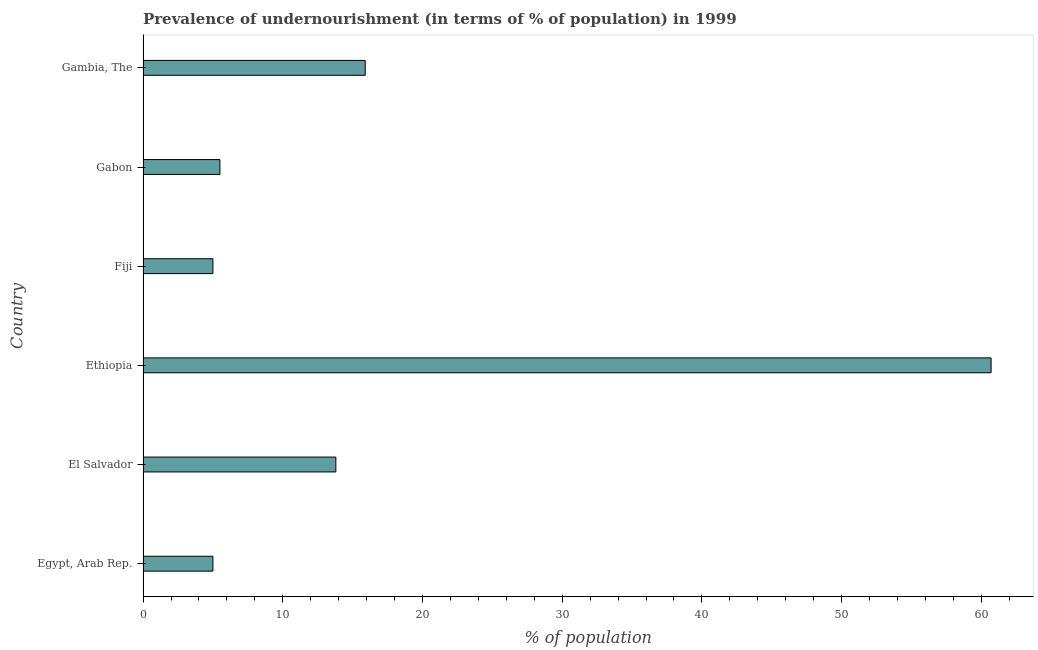What is the title of the graph?
Give a very brief answer. Prevalence of undernourishment (in terms of % of population) in 1999. What is the label or title of the X-axis?
Give a very brief answer. % of population. Across all countries, what is the maximum percentage of undernourished population?
Offer a very short reply. 60.7. In which country was the percentage of undernourished population maximum?
Give a very brief answer. Ethiopia. In which country was the percentage of undernourished population minimum?
Your answer should be compact. Egypt, Arab Rep. What is the sum of the percentage of undernourished population?
Keep it short and to the point. 105.9. What is the difference between the percentage of undernourished population in Ethiopia and Gambia, The?
Offer a very short reply. 44.8. What is the average percentage of undernourished population per country?
Offer a very short reply. 17.65. What is the median percentage of undernourished population?
Provide a short and direct response. 9.65. In how many countries, is the percentage of undernourished population greater than 26 %?
Your answer should be compact. 1. Is the difference between the percentage of undernourished population in Ethiopia and Fiji greater than the difference between any two countries?
Offer a terse response. Yes. What is the difference between the highest and the second highest percentage of undernourished population?
Offer a very short reply. 44.8. Is the sum of the percentage of undernourished population in El Salvador and Fiji greater than the maximum percentage of undernourished population across all countries?
Give a very brief answer. No. What is the difference between the highest and the lowest percentage of undernourished population?
Give a very brief answer. 55.7. How many countries are there in the graph?
Offer a very short reply. 6. What is the difference between two consecutive major ticks on the X-axis?
Provide a short and direct response. 10. Are the values on the major ticks of X-axis written in scientific E-notation?
Provide a succinct answer. No. What is the % of population of Egypt, Arab Rep.?
Give a very brief answer. 5. What is the % of population in Ethiopia?
Your answer should be very brief. 60.7. What is the % of population of Gambia, The?
Provide a short and direct response. 15.9. What is the difference between the % of population in Egypt, Arab Rep. and Ethiopia?
Your answer should be compact. -55.7. What is the difference between the % of population in Egypt, Arab Rep. and Fiji?
Make the answer very short. 0. What is the difference between the % of population in El Salvador and Ethiopia?
Provide a succinct answer. -46.9. What is the difference between the % of population in El Salvador and Fiji?
Make the answer very short. 8.8. What is the difference between the % of population in El Salvador and Gabon?
Provide a short and direct response. 8.3. What is the difference between the % of population in El Salvador and Gambia, The?
Your response must be concise. -2.1. What is the difference between the % of population in Ethiopia and Fiji?
Your answer should be compact. 55.7. What is the difference between the % of population in Ethiopia and Gabon?
Offer a very short reply. 55.2. What is the difference between the % of population in Ethiopia and Gambia, The?
Offer a terse response. 44.8. What is the difference between the % of population in Fiji and Gabon?
Provide a short and direct response. -0.5. What is the difference between the % of population in Fiji and Gambia, The?
Your answer should be compact. -10.9. What is the difference between the % of population in Gabon and Gambia, The?
Your response must be concise. -10.4. What is the ratio of the % of population in Egypt, Arab Rep. to that in El Salvador?
Provide a short and direct response. 0.36. What is the ratio of the % of population in Egypt, Arab Rep. to that in Ethiopia?
Your answer should be compact. 0.08. What is the ratio of the % of population in Egypt, Arab Rep. to that in Fiji?
Your answer should be very brief. 1. What is the ratio of the % of population in Egypt, Arab Rep. to that in Gabon?
Offer a terse response. 0.91. What is the ratio of the % of population in Egypt, Arab Rep. to that in Gambia, The?
Ensure brevity in your answer.  0.31. What is the ratio of the % of population in El Salvador to that in Ethiopia?
Ensure brevity in your answer.  0.23. What is the ratio of the % of population in El Salvador to that in Fiji?
Offer a very short reply. 2.76. What is the ratio of the % of population in El Salvador to that in Gabon?
Give a very brief answer. 2.51. What is the ratio of the % of population in El Salvador to that in Gambia, The?
Your answer should be compact. 0.87. What is the ratio of the % of population in Ethiopia to that in Fiji?
Your answer should be compact. 12.14. What is the ratio of the % of population in Ethiopia to that in Gabon?
Offer a very short reply. 11.04. What is the ratio of the % of population in Ethiopia to that in Gambia, The?
Your answer should be very brief. 3.82. What is the ratio of the % of population in Fiji to that in Gabon?
Make the answer very short. 0.91. What is the ratio of the % of population in Fiji to that in Gambia, The?
Your answer should be compact. 0.31. What is the ratio of the % of population in Gabon to that in Gambia, The?
Make the answer very short. 0.35. 